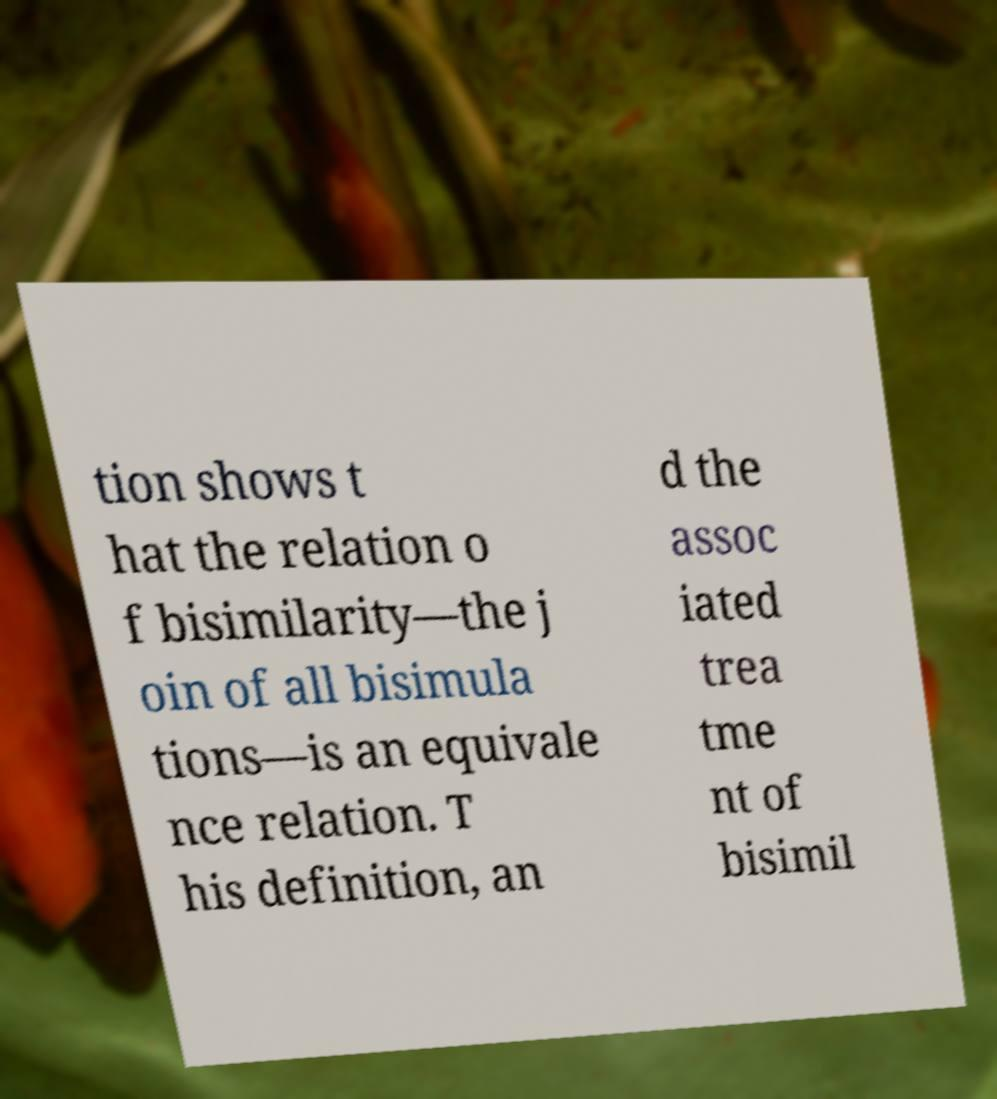Can you read and provide the text displayed in the image?This photo seems to have some interesting text. Can you extract and type it out for me? tion shows t hat the relation o f bisimilarity—the j oin of all bisimula tions—is an equivale nce relation. T his definition, an d the assoc iated trea tme nt of bisimil 